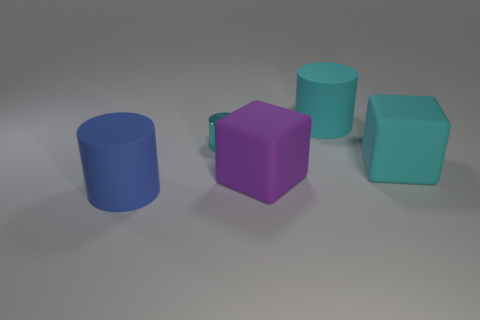How many cyan cylinders must be subtracted to get 1 cyan cylinders? 1 Add 1 small gray rubber blocks. How many objects exist? 6 Subtract all cyan cylinders. How many cylinders are left? 1 Subtract all cyan blocks. Subtract all purple cylinders. How many blocks are left? 1 Subtract all gray cylinders. How many cyan cubes are left? 1 Subtract all blue matte things. Subtract all small objects. How many objects are left? 3 Add 4 purple blocks. How many purple blocks are left? 5 Add 1 blue things. How many blue things exist? 2 Subtract all cyan blocks. How many blocks are left? 1 Subtract 0 yellow balls. How many objects are left? 5 